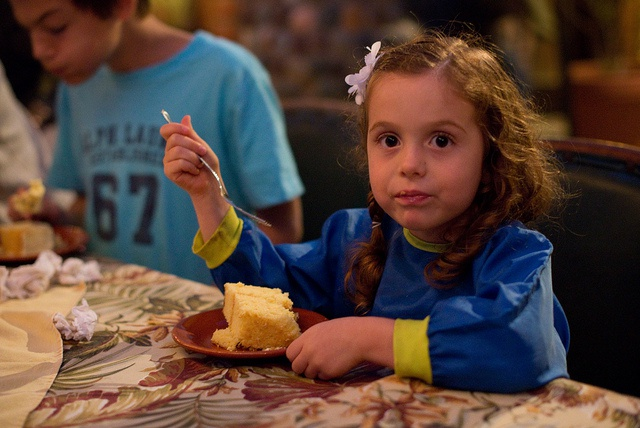Describe the objects in this image and their specific colors. I can see people in black, navy, maroon, and brown tones, people in black, blue, maroon, and gray tones, dining table in black, gray, tan, and maroon tones, chair in black, maroon, and olive tones, and chair in black, maroon, and navy tones in this image. 